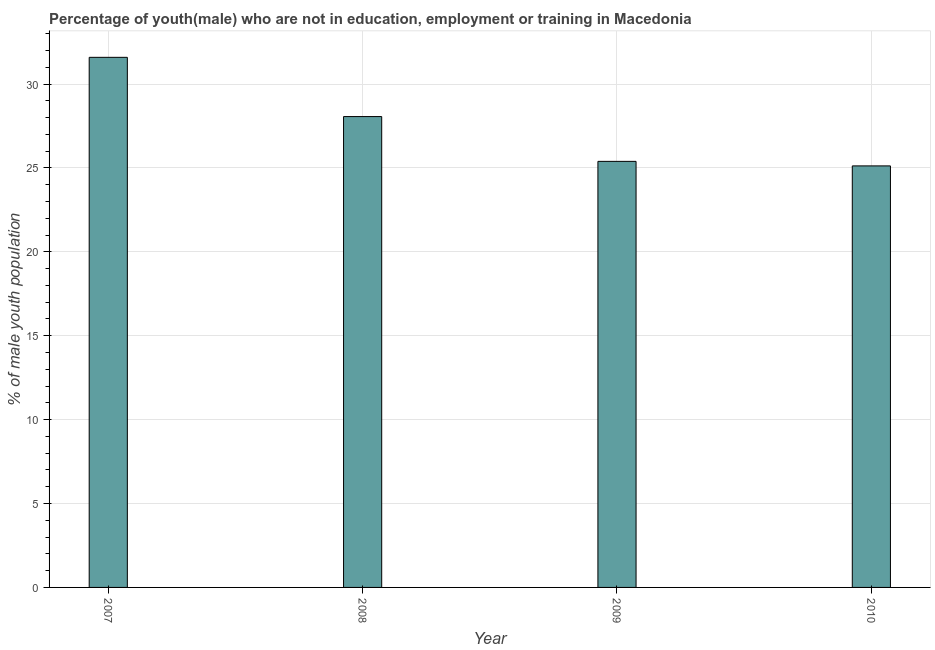Does the graph contain any zero values?
Offer a terse response. No. What is the title of the graph?
Give a very brief answer. Percentage of youth(male) who are not in education, employment or training in Macedonia. What is the label or title of the X-axis?
Provide a succinct answer. Year. What is the label or title of the Y-axis?
Offer a terse response. % of male youth population. What is the unemployed male youth population in 2007?
Offer a very short reply. 31.59. Across all years, what is the maximum unemployed male youth population?
Provide a short and direct response. 31.59. Across all years, what is the minimum unemployed male youth population?
Provide a short and direct response. 25.12. In which year was the unemployed male youth population maximum?
Provide a short and direct response. 2007. What is the sum of the unemployed male youth population?
Make the answer very short. 110.16. What is the difference between the unemployed male youth population in 2007 and 2010?
Give a very brief answer. 6.47. What is the average unemployed male youth population per year?
Offer a very short reply. 27.54. What is the median unemployed male youth population?
Provide a succinct answer. 26.72. Do a majority of the years between 2009 and 2007 (inclusive) have unemployed male youth population greater than 10 %?
Provide a succinct answer. Yes. What is the ratio of the unemployed male youth population in 2007 to that in 2008?
Offer a very short reply. 1.13. Is the unemployed male youth population in 2009 less than that in 2010?
Provide a succinct answer. No. What is the difference between the highest and the second highest unemployed male youth population?
Offer a very short reply. 3.53. What is the difference between the highest and the lowest unemployed male youth population?
Make the answer very short. 6.47. Are the values on the major ticks of Y-axis written in scientific E-notation?
Provide a succinct answer. No. What is the % of male youth population of 2007?
Provide a succinct answer. 31.59. What is the % of male youth population in 2008?
Offer a terse response. 28.06. What is the % of male youth population of 2009?
Ensure brevity in your answer.  25.39. What is the % of male youth population in 2010?
Keep it short and to the point. 25.12. What is the difference between the % of male youth population in 2007 and 2008?
Your answer should be compact. 3.53. What is the difference between the % of male youth population in 2007 and 2009?
Give a very brief answer. 6.2. What is the difference between the % of male youth population in 2007 and 2010?
Provide a succinct answer. 6.47. What is the difference between the % of male youth population in 2008 and 2009?
Ensure brevity in your answer.  2.67. What is the difference between the % of male youth population in 2008 and 2010?
Provide a short and direct response. 2.94. What is the difference between the % of male youth population in 2009 and 2010?
Keep it short and to the point. 0.27. What is the ratio of the % of male youth population in 2007 to that in 2008?
Your answer should be very brief. 1.13. What is the ratio of the % of male youth population in 2007 to that in 2009?
Give a very brief answer. 1.24. What is the ratio of the % of male youth population in 2007 to that in 2010?
Offer a terse response. 1.26. What is the ratio of the % of male youth population in 2008 to that in 2009?
Your answer should be compact. 1.1. What is the ratio of the % of male youth population in 2008 to that in 2010?
Your answer should be very brief. 1.12. What is the ratio of the % of male youth population in 2009 to that in 2010?
Give a very brief answer. 1.01. 